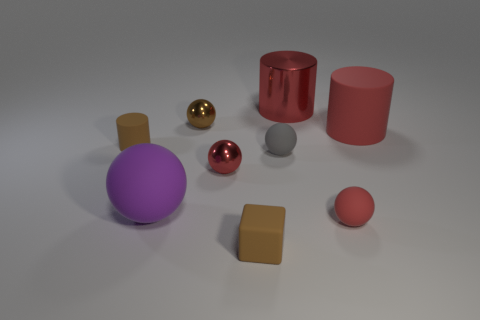Subtract 2 spheres. How many spheres are left? 3 Subtract all green cylinders. Subtract all cyan spheres. How many cylinders are left? 3 Add 1 tiny brown blocks. How many objects exist? 10 Subtract all cylinders. How many objects are left? 6 Add 8 large red cylinders. How many large red cylinders exist? 10 Subtract 0 gray blocks. How many objects are left? 9 Subtract all big spheres. Subtract all green metallic things. How many objects are left? 8 Add 9 large purple spheres. How many large purple spheres are left? 10 